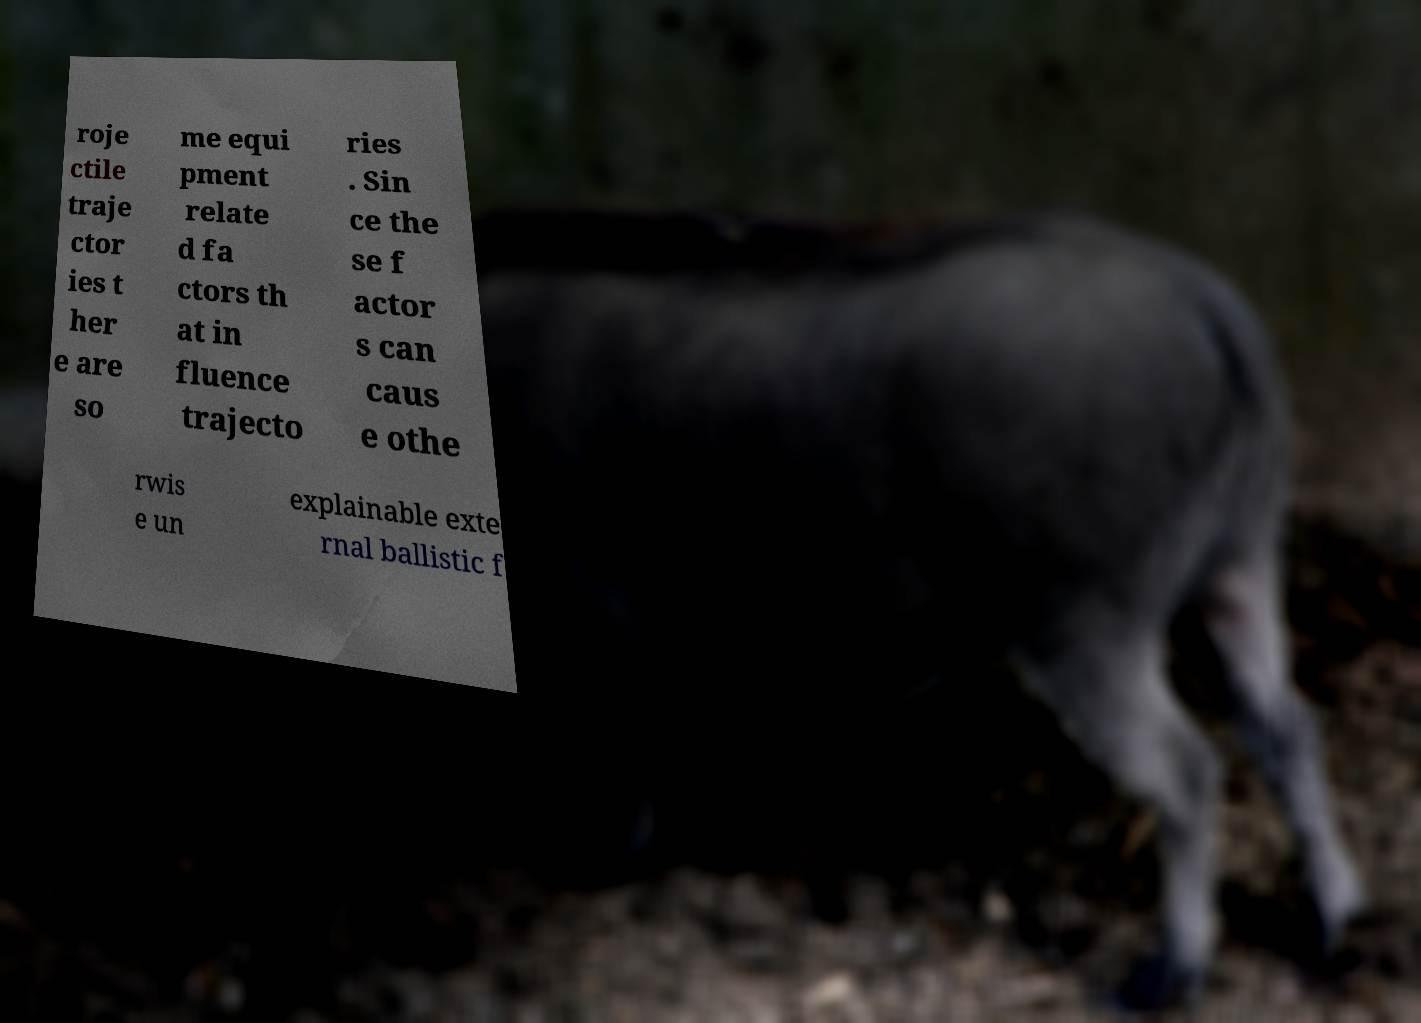Could you assist in decoding the text presented in this image and type it out clearly? roje ctile traje ctor ies t her e are so me equi pment relate d fa ctors th at in fluence trajecto ries . Sin ce the se f actor s can caus e othe rwis e un explainable exte rnal ballistic f 